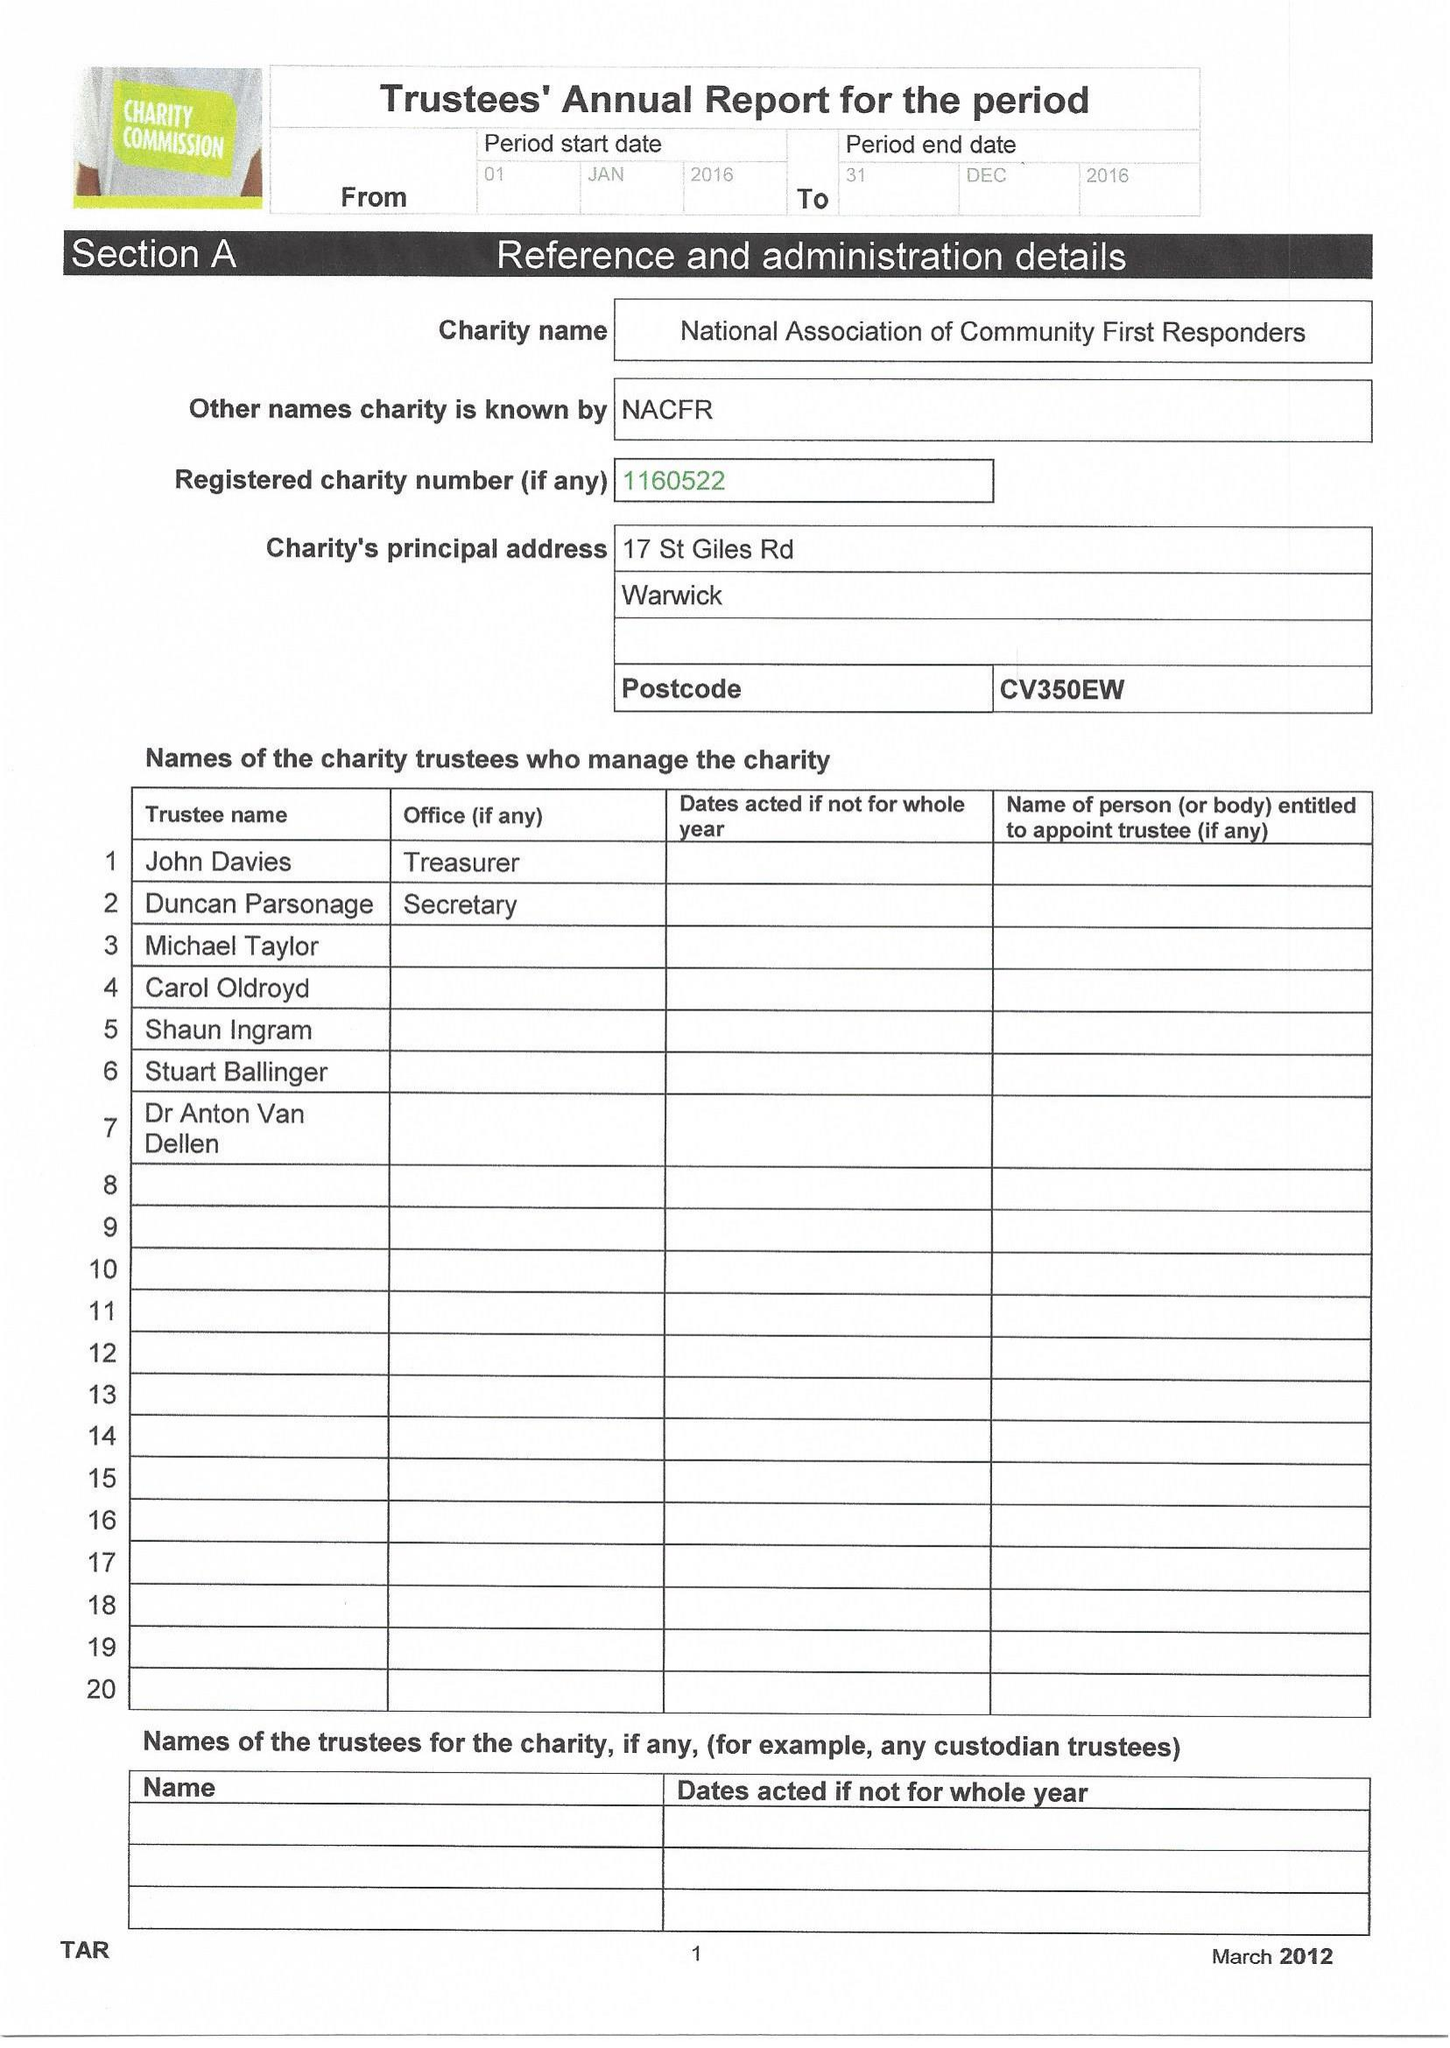What is the value for the charity_number?
Answer the question using a single word or phrase. 1160522 